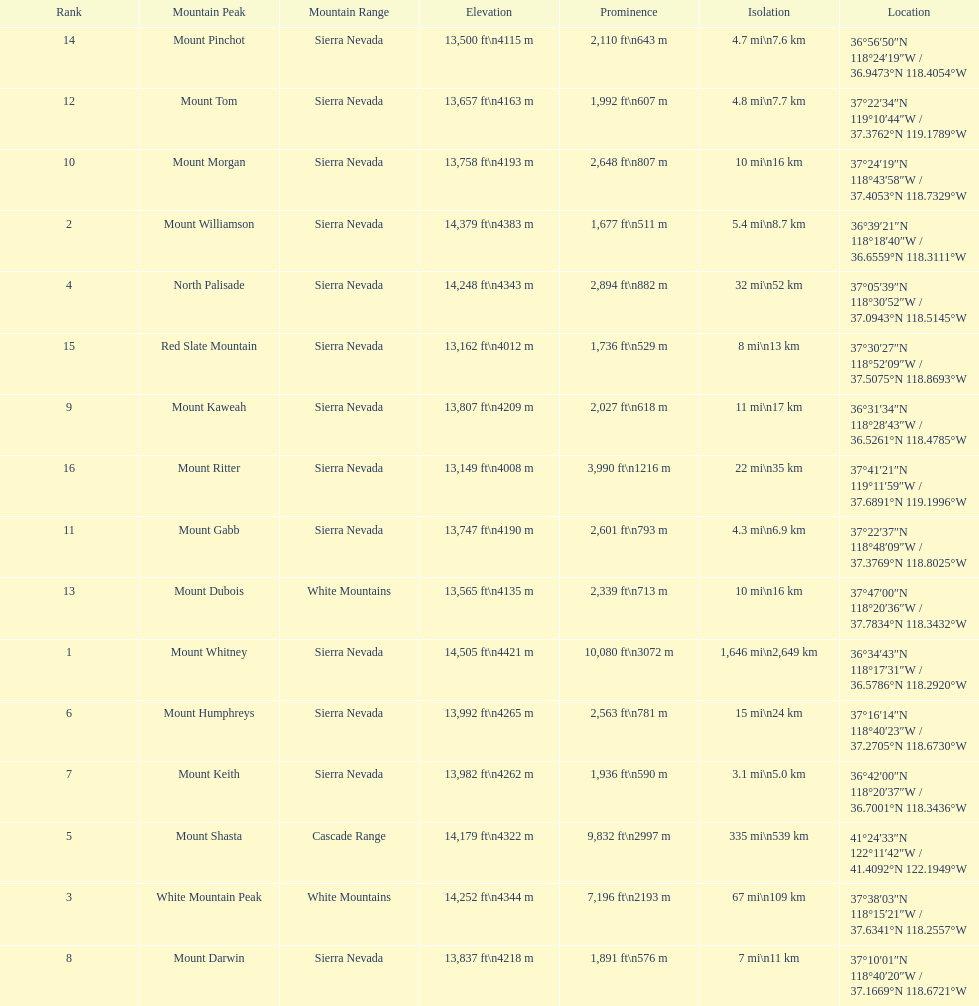How much taller is the mountain peak of mount williamson than that of mount keith? 397 ft. Would you be able to parse every entry in this table? {'header': ['Rank', 'Mountain Peak', 'Mountain Range', 'Elevation', 'Prominence', 'Isolation', 'Location'], 'rows': [['14', 'Mount Pinchot', 'Sierra Nevada', '13,500\xa0ft\\n4115\xa0m', '2,110\xa0ft\\n643\xa0m', '4.7\xa0mi\\n7.6\xa0km', '36°56′50″N 118°24′19″W\ufeff / \ufeff36.9473°N 118.4054°W'], ['12', 'Mount Tom', 'Sierra Nevada', '13,657\xa0ft\\n4163\xa0m', '1,992\xa0ft\\n607\xa0m', '4.8\xa0mi\\n7.7\xa0km', '37°22′34″N 119°10′44″W\ufeff / \ufeff37.3762°N 119.1789°W'], ['10', 'Mount Morgan', 'Sierra Nevada', '13,758\xa0ft\\n4193\xa0m', '2,648\xa0ft\\n807\xa0m', '10\xa0mi\\n16\xa0km', '37°24′19″N 118°43′58″W\ufeff / \ufeff37.4053°N 118.7329°W'], ['2', 'Mount Williamson', 'Sierra Nevada', '14,379\xa0ft\\n4383\xa0m', '1,677\xa0ft\\n511\xa0m', '5.4\xa0mi\\n8.7\xa0km', '36°39′21″N 118°18′40″W\ufeff / \ufeff36.6559°N 118.3111°W'], ['4', 'North Palisade', 'Sierra Nevada', '14,248\xa0ft\\n4343\xa0m', '2,894\xa0ft\\n882\xa0m', '32\xa0mi\\n52\xa0km', '37°05′39″N 118°30′52″W\ufeff / \ufeff37.0943°N 118.5145°W'], ['15', 'Red Slate Mountain', 'Sierra Nevada', '13,162\xa0ft\\n4012\xa0m', '1,736\xa0ft\\n529\xa0m', '8\xa0mi\\n13\xa0km', '37°30′27″N 118°52′09″W\ufeff / \ufeff37.5075°N 118.8693°W'], ['9', 'Mount Kaweah', 'Sierra Nevada', '13,807\xa0ft\\n4209\xa0m', '2,027\xa0ft\\n618\xa0m', '11\xa0mi\\n17\xa0km', '36°31′34″N 118°28′43″W\ufeff / \ufeff36.5261°N 118.4785°W'], ['16', 'Mount Ritter', 'Sierra Nevada', '13,149\xa0ft\\n4008\xa0m', '3,990\xa0ft\\n1216\xa0m', '22\xa0mi\\n35\xa0km', '37°41′21″N 119°11′59″W\ufeff / \ufeff37.6891°N 119.1996°W'], ['11', 'Mount Gabb', 'Sierra Nevada', '13,747\xa0ft\\n4190\xa0m', '2,601\xa0ft\\n793\xa0m', '4.3\xa0mi\\n6.9\xa0km', '37°22′37″N 118°48′09″W\ufeff / \ufeff37.3769°N 118.8025°W'], ['13', 'Mount Dubois', 'White Mountains', '13,565\xa0ft\\n4135\xa0m', '2,339\xa0ft\\n713\xa0m', '10\xa0mi\\n16\xa0km', '37°47′00″N 118°20′36″W\ufeff / \ufeff37.7834°N 118.3432°W'], ['1', 'Mount Whitney', 'Sierra Nevada', '14,505\xa0ft\\n4421\xa0m', '10,080\xa0ft\\n3072\xa0m', '1,646\xa0mi\\n2,649\xa0km', '36°34′43″N 118°17′31″W\ufeff / \ufeff36.5786°N 118.2920°W'], ['6', 'Mount Humphreys', 'Sierra Nevada', '13,992\xa0ft\\n4265\xa0m', '2,563\xa0ft\\n781\xa0m', '15\xa0mi\\n24\xa0km', '37°16′14″N 118°40′23″W\ufeff / \ufeff37.2705°N 118.6730°W'], ['7', 'Mount Keith', 'Sierra Nevada', '13,982\xa0ft\\n4262\xa0m', '1,936\xa0ft\\n590\xa0m', '3.1\xa0mi\\n5.0\xa0km', '36°42′00″N 118°20′37″W\ufeff / \ufeff36.7001°N 118.3436°W'], ['5', 'Mount Shasta', 'Cascade Range', '14,179\xa0ft\\n4322\xa0m', '9,832\xa0ft\\n2997\xa0m', '335\xa0mi\\n539\xa0km', '41°24′33″N 122°11′42″W\ufeff / \ufeff41.4092°N 122.1949°W'], ['3', 'White Mountain Peak', 'White Mountains', '14,252\xa0ft\\n4344\xa0m', '7,196\xa0ft\\n2193\xa0m', '67\xa0mi\\n109\xa0km', '37°38′03″N 118°15′21″W\ufeff / \ufeff37.6341°N 118.2557°W'], ['8', 'Mount Darwin', 'Sierra Nevada', '13,837\xa0ft\\n4218\xa0m', '1,891\xa0ft\\n576\xa0m', '7\xa0mi\\n11\xa0km', '37°10′01″N 118°40′20″W\ufeff / \ufeff37.1669°N 118.6721°W']]} 